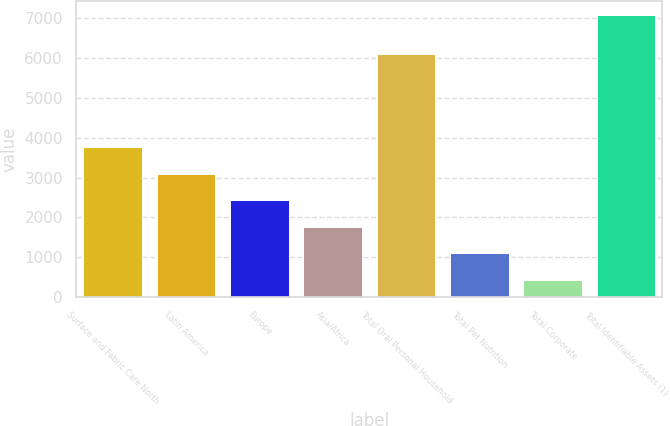Convert chart. <chart><loc_0><loc_0><loc_500><loc_500><bar_chart><fcel>Surface and Fabric Care North<fcel>Latin America<fcel>Europe<fcel>Asia/Africa<fcel>Total Oral Personal Household<fcel>Total Pet Nutrition<fcel>Total Corporate<fcel>Total Identifiable Assets (1)<nl><fcel>3759.5<fcel>3093.96<fcel>2428.42<fcel>1762.88<fcel>6102.9<fcel>1097.34<fcel>431.8<fcel>7087.2<nl></chart> 